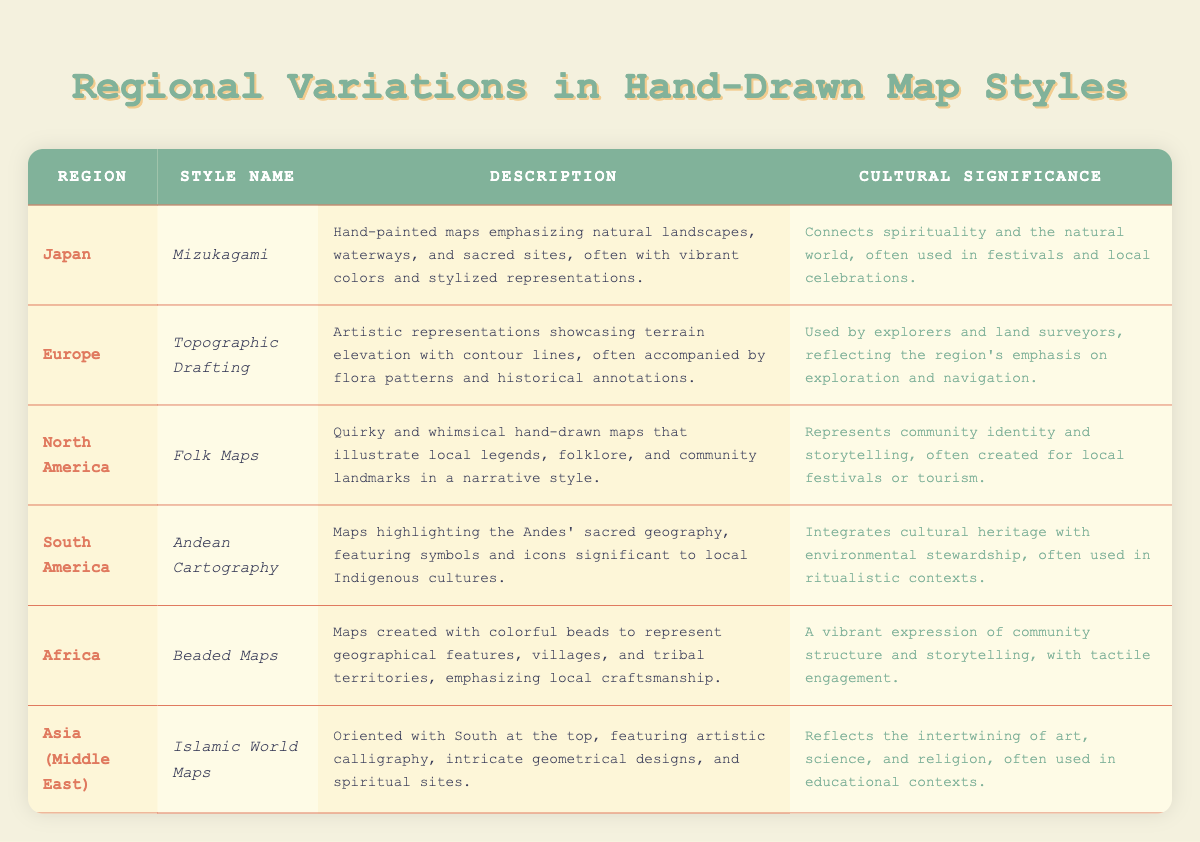What is the style name for hand-drawn maps from Japan? The table lists the region of Japan along with the corresponding style name, which is Mizukagami.
Answer: Mizukagami Which regions have map styles that emphasize storytelling? The table indicates that both North America (Folk Maps) and Africa (Beaded Maps) have styles that highlight community identity and storytelling.
Answer: North America and Africa Do Islamic World Maps feature artistic elements? The description for Islamic World Maps states that they include artistic calligraphy and intricate geometrical designs. Therefore, the statement is true.
Answer: Yes How many regions have hand-drawn map styles that incorporate elements of community identity? Both North America and Africa have map styles that reflect community identity. Hence, there are two regions.
Answer: 2 What is the cultural significance of Andean Cartography? The cultural significance of Andean Cartography is stated as integrating cultural heritage with environmental stewardship, often used in ritualistic contexts.
Answer: Integrates cultural heritage with environmental stewardship Are the map styles created in Europe reflective of artistic representations for explorers? Yes, the table notes that the Topographic Drafting style was used by explorers and land surveyors, highlighting their connection to exploration and navigation.
Answer: Yes Which regional style emphasizes spiritual connections to nature? The Mizukagami style from Japan is described as connecting spirituality and the natural world through its vibrant representations.
Answer: Mizukagami If we consider all the styles mentioned, how many emphasize environmental elements (like sacred geography or natural landscapes)? The Mizukagami, Andean Cartography, and Topographic Drafting incorporate environmental elements. Counting them gives a total of three map styles emphasizing this aspect.
Answer: 3 